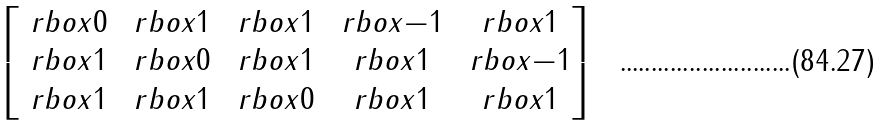<formula> <loc_0><loc_0><loc_500><loc_500>\begin{bmatrix} \ r b o x { 0 } & \ r b o x { 1 } & \ r b o x { 1 } & \ r b o x { - 1 } & \ r b o x { 1 } \\ \ r b o x { 1 } & \ r b o x { 0 } & \ r b o x { 1 } & \ r b o x { 1 } & \ r b o x { - 1 } \\ \ r b o x { 1 } & \ r b o x { 1 } & \ r b o x { 0 } & \ r b o x { 1 } & \ r b o x { 1 } \end{bmatrix}</formula> 